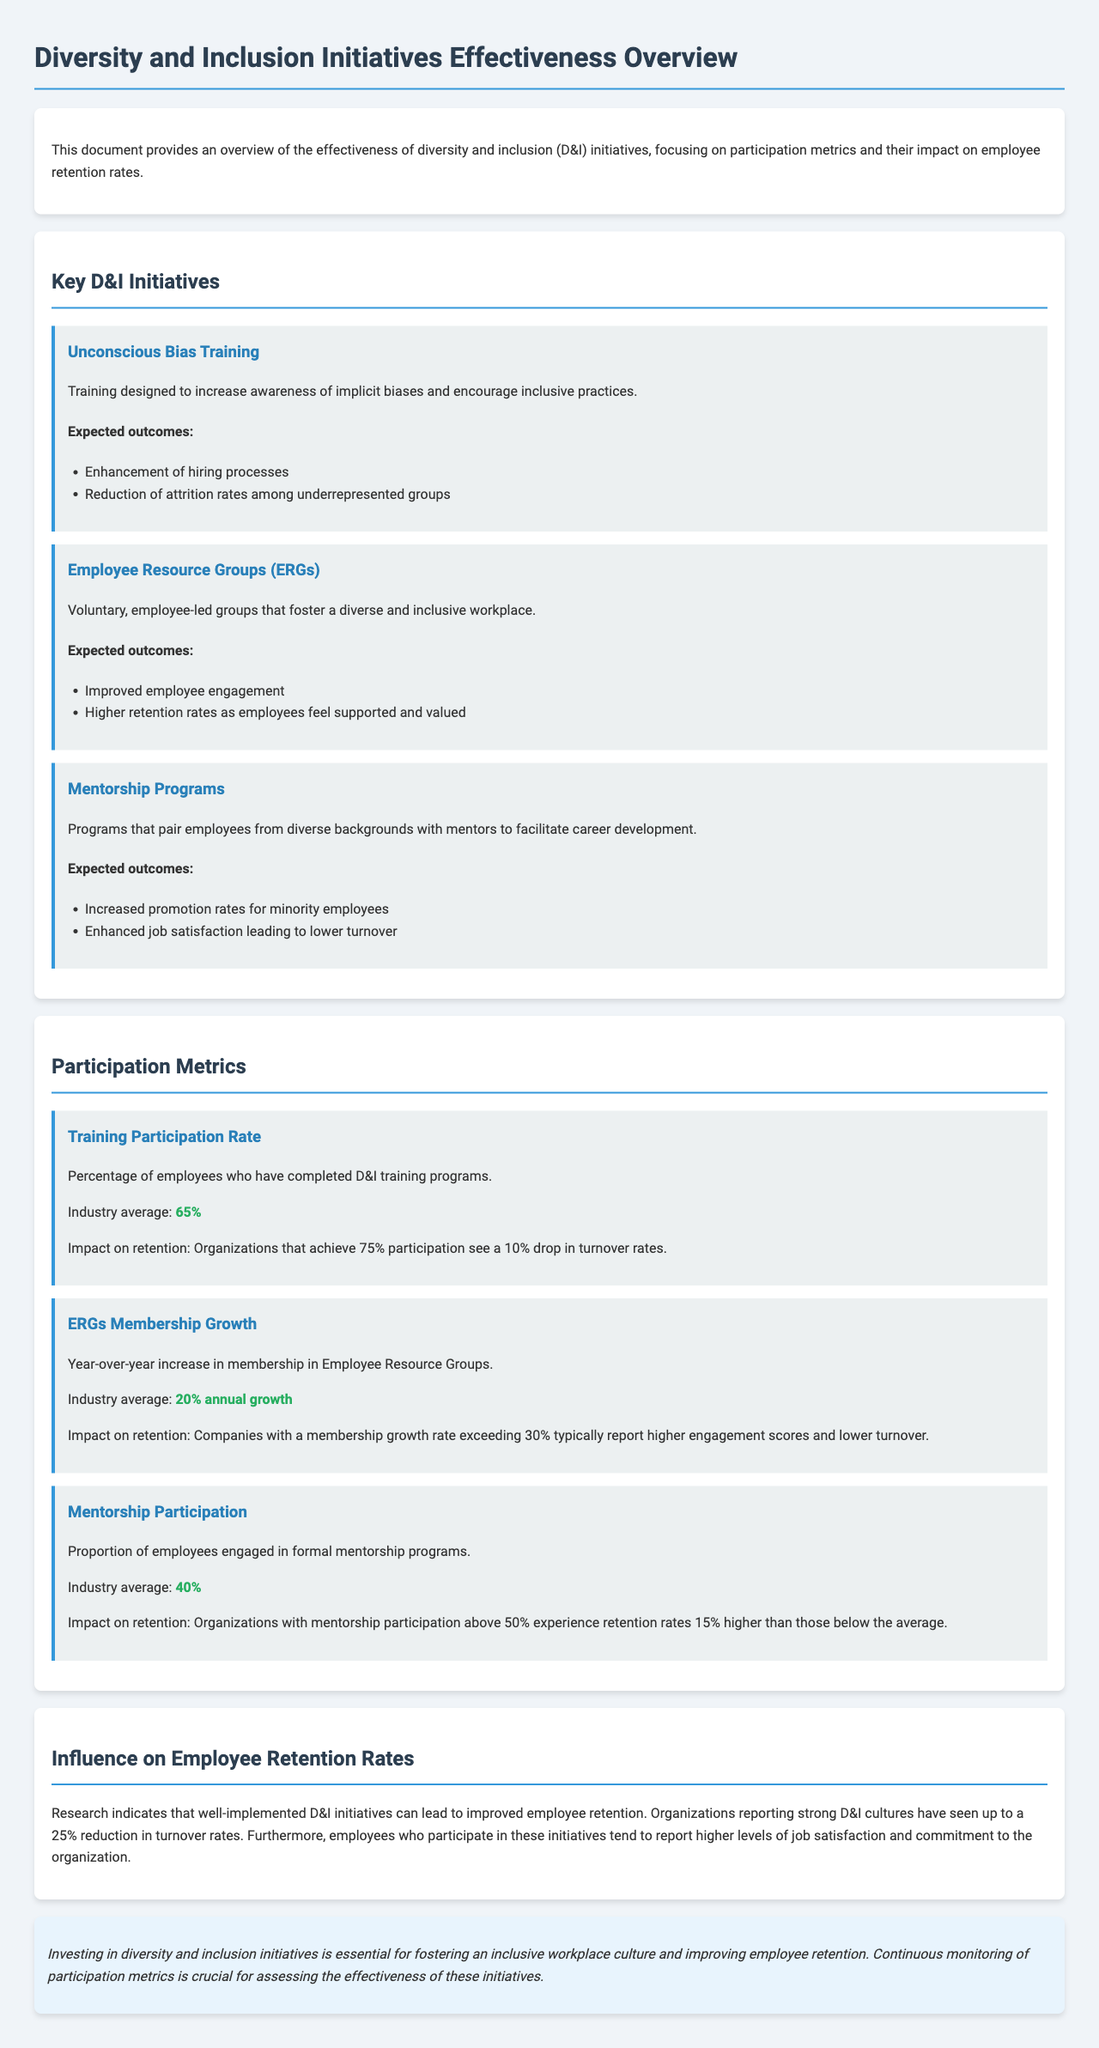What is the purpose of the document? The document provides an overview of the effectiveness of diversity and inclusion initiatives, focusing on participation metrics and their impact on employee retention rates.
Answer: Overview of D&I initiatives effectiveness What is the industry average for training participation rate? The document states that the industry average for training participation rate is given as 65%.
Answer: 65% What percentage of turnover reduction is associated with 75% participation in training? The document indicates that organizations achieving 75% participation see a 10% drop in turnover rates.
Answer: 10% What is the expected outcome of the Employee Resource Groups? The expected outcome of the Employee Resource Groups is higher retention rates as employees feel supported and valued.
Answer: Higher retention rates What is the industry average annual growth for ERGs membership? The document states that the industry average for ERGs membership growth is 20% annual growth.
Answer: 20% annual growth How much higher are retention rates for organizations with mentorship participation above 50%? The document mentions that organizations with mentorship participation above 50% experience retention rates 15% higher than those below the average.
Answer: 15% What is the potential reduction in turnover rates reported by organizations with strong D&I cultures? The document states that organizations reporting strong D&I cultures have seen up to a 25% reduction in turnover rates.
Answer: 25% What is emphasized as essential for improving employee retention? The document emphasizes that investing in diversity and inclusion initiatives is essential for fostering an inclusive workplace culture and improving employee retention.
Answer: Investing in D&I initiatives 